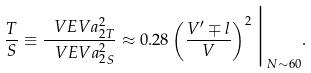<formula> <loc_0><loc_0><loc_500><loc_500>\frac { T } { S } \equiv \frac { \ V E V { a _ { 2 } ^ { 2 } } _ { T } } { \ V E V { a _ { 2 } ^ { 2 } } _ { S } } \approx 0 . 2 8 \left ( \frac { V ^ { \prime } \mp l } { V } \right ) ^ { 2 } \Big | _ { N \sim 6 0 } .</formula> 